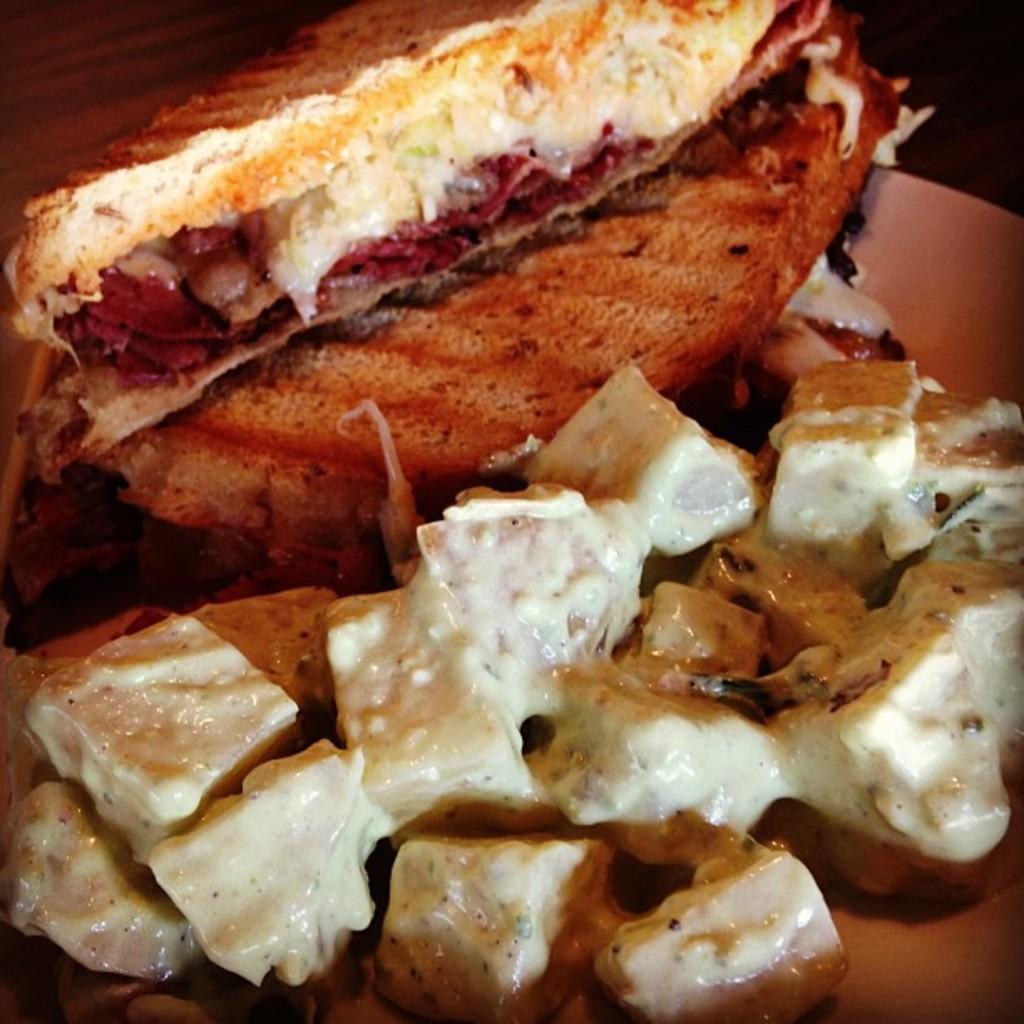What is on the plate that is visible in the image? There is a plate with food in the image. Where is the plate located in the image? The plate is on a surface in the image. What color is the background of the image? The background of the image is black. How many shoes can be seen in the image? There are no shoes present in the image. What type of cracker is visible in the image? There is no cracker present in the image. 